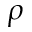Convert formula to latex. <formula><loc_0><loc_0><loc_500><loc_500>\rho</formula> 